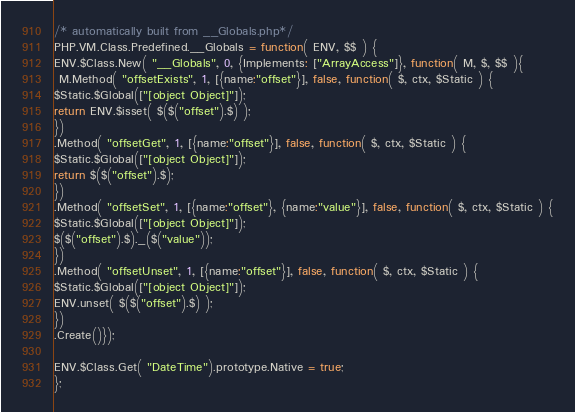<code> <loc_0><loc_0><loc_500><loc_500><_JavaScript_>/* automatically built from __Globals.php*/
PHP.VM.Class.Predefined.__Globals = function( ENV, $$ ) {
ENV.$Class.New( "__Globals", 0, {Implements: ["ArrayAccess"]}, function( M, $, $$ ){
 M.Method( "offsetExists", 1, [{name:"offset"}], false, function( $, ctx, $Static ) {
$Static.$Global(["[object Object]"]);
return ENV.$isset( $($("offset").$) );
})
.Method( "offsetGet", 1, [{name:"offset"}], false, function( $, ctx, $Static ) {
$Static.$Global(["[object Object]"]);
return $($("offset").$);
})
.Method( "offsetSet", 1, [{name:"offset"}, {name:"value"}], false, function( $, ctx, $Static ) {
$Static.$Global(["[object Object]"]);
$($("offset").$)._($("value"));
})
.Method( "offsetUnset", 1, [{name:"offset"}], false, function( $, ctx, $Static ) {
$Static.$Global(["[object Object]"]);
ENV.unset( $($("offset").$) );
})
.Create()});

ENV.$Class.Get( "DateTime").prototype.Native = true;
};</code> 